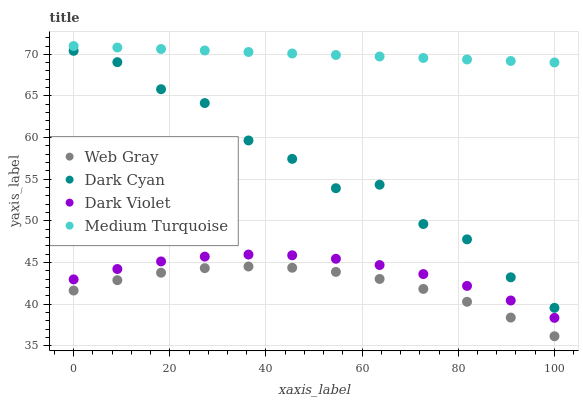Does Web Gray have the minimum area under the curve?
Answer yes or no. Yes. Does Medium Turquoise have the maximum area under the curve?
Answer yes or no. Yes. Does Medium Turquoise have the minimum area under the curve?
Answer yes or no. No. Does Web Gray have the maximum area under the curve?
Answer yes or no. No. Is Medium Turquoise the smoothest?
Answer yes or no. Yes. Is Dark Cyan the roughest?
Answer yes or no. Yes. Is Web Gray the smoothest?
Answer yes or no. No. Is Web Gray the roughest?
Answer yes or no. No. Does Web Gray have the lowest value?
Answer yes or no. Yes. Does Medium Turquoise have the lowest value?
Answer yes or no. No. Does Medium Turquoise have the highest value?
Answer yes or no. Yes. Does Web Gray have the highest value?
Answer yes or no. No. Is Web Gray less than Medium Turquoise?
Answer yes or no. Yes. Is Medium Turquoise greater than Web Gray?
Answer yes or no. Yes. Does Web Gray intersect Medium Turquoise?
Answer yes or no. No. 